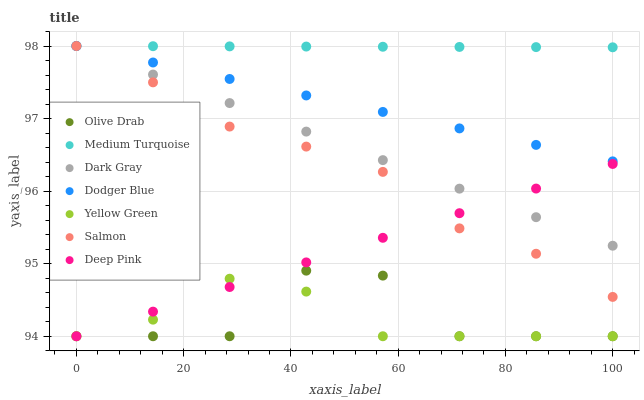Does Yellow Green have the minimum area under the curve?
Answer yes or no. Yes. Does Medium Turquoise have the maximum area under the curve?
Answer yes or no. Yes. Does Salmon have the minimum area under the curve?
Answer yes or no. No. Does Salmon have the maximum area under the curve?
Answer yes or no. No. Is Deep Pink the smoothest?
Answer yes or no. Yes. Is Olive Drab the roughest?
Answer yes or no. Yes. Is Yellow Green the smoothest?
Answer yes or no. No. Is Yellow Green the roughest?
Answer yes or no. No. Does Deep Pink have the lowest value?
Answer yes or no. Yes. Does Salmon have the lowest value?
Answer yes or no. No. Does Medium Turquoise have the highest value?
Answer yes or no. Yes. Does Yellow Green have the highest value?
Answer yes or no. No. Is Deep Pink less than Medium Turquoise?
Answer yes or no. Yes. Is Dodger Blue greater than Deep Pink?
Answer yes or no. Yes. Does Yellow Green intersect Deep Pink?
Answer yes or no. Yes. Is Yellow Green less than Deep Pink?
Answer yes or no. No. Is Yellow Green greater than Deep Pink?
Answer yes or no. No. Does Deep Pink intersect Medium Turquoise?
Answer yes or no. No. 